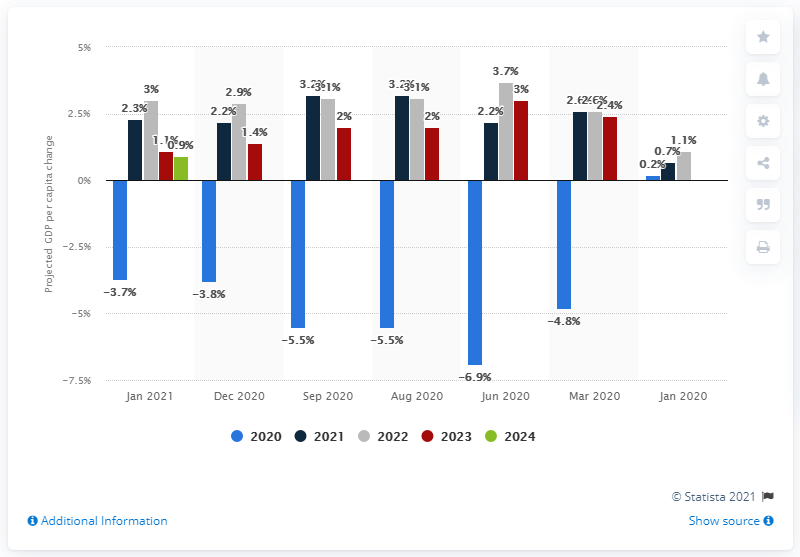Point out several critical features in this image. According to the forecast, Sweden's GDP per capita was expected to experience a negative growth rate in 2020, at 3.7... 